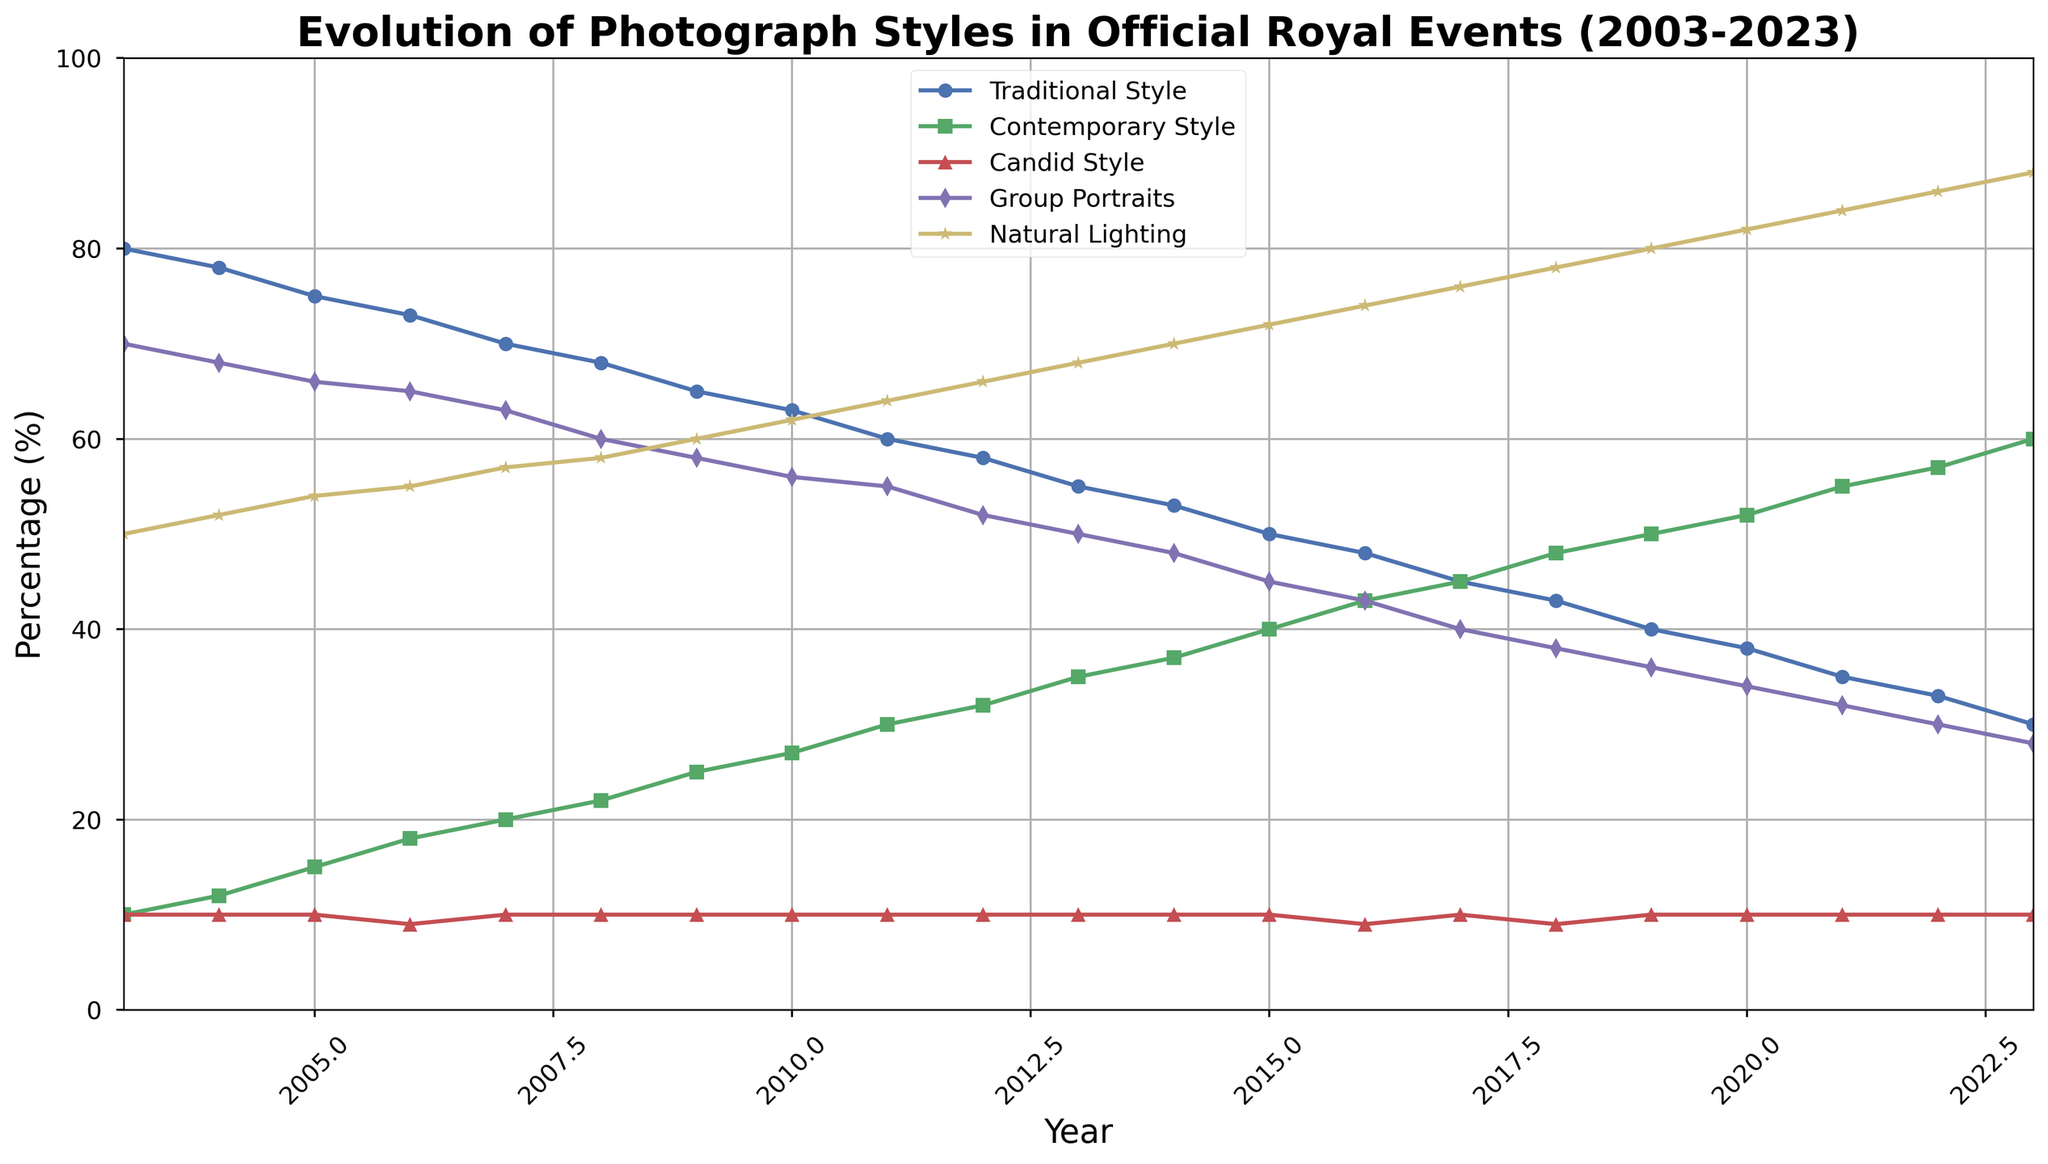What is the trend of Traditional Style photography from 2003 to 2023? By examining the line plot for Traditional Style, the percentage has steadily decreased from 80% in 2003 to 30% in 2023.
Answer: It is decreasing Which style had the highest percentage in 2023? In 2023, the style with the highest percentage is Natural Lighting, as seen from its line reaching the top of the plot at 88%.
Answer: Natural Lighting Between which years did Contemporary Style exceed Traditional Style in percentage? The plot shows that Contemporary Style exceeds Traditional Style percentages starting from 2015.
Answer: From 2015 onwards Calculate the average percentage of Group Portraits over the 20 years. Adding the percentage values of Group Portraits from each year starting from 2003 to 2023 and dividing by 21 (number of years), the average can be computed as follows: (70 + 68 + 66 + 65 + 63 + 60 + 58 + 56 + 55 + 52 + 50 + 48 + 45 + 43 + 40 + 38 + 36 + 34 + 32 + 30 + 28)/21 = 50.43%.
Answer: 50.43% Is there any year where all styles have exactly 10%? By inspecting the plot data for each year, there are different trends and none of the years show all styles having exactly 10%.
Answer: No Which year marks the highest growth in Contemporary Style compared to the previous year? Observing the yearly increments, the highest increase occurs from 2021 to 2022, where percentage increases from 55% to 57%, a 2% increase.
Answer: Between 2021 and 2022 Compare the percentage of Natural Lighting in 2005 and 2023 and state which year had the higher percentage. Referring to the line plot, in 2005, Natural Lighting is at 54% whereas in 2023, it is at 88%. Thus, 2023 had a higher percentage.
Answer: 2023 What is the difference in percentage of Candid Style between 2006 and 2018? In 2006, Candid Style is at 9% and remains at 9% in 2018. The difference is 0%.
Answer: 0% By how much did the percentage of Group Portraits decrease from 2003 to 2023? The difference in Group Portraits between 2003 and 2023 can be calculated as: 70% in 2003 - 28% in 2023 = 42%.
Answer: 42% Which styles had a steady percentage over the 20 years? By examining the line plots, Candid Style had a consistent percentage hovering around 10%.
Answer: Candid Style 